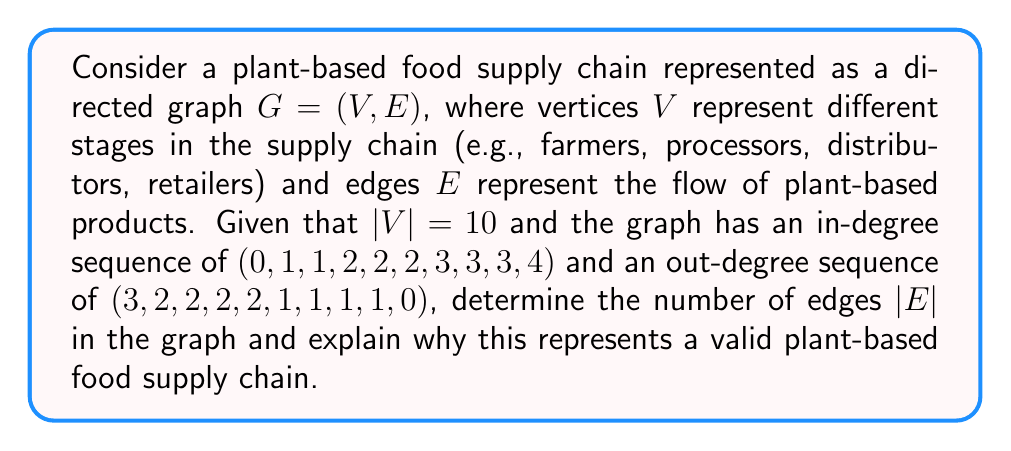Solve this math problem. To solve this problem, we'll follow these steps:

1) First, recall that in a directed graph, the sum of in-degrees equals the sum of out-degrees, which equals the total number of edges. Let's verify this:

   Sum of in-degrees: $0 + 1 + 1 + 2 + 2 + 2 + 3 + 3 + 3 + 4 = 21$
   Sum of out-degrees: $3 + 2 + 2 + 2 + 2 + 1 + 1 + 1 + 1 + 0 = 15$

2) We see that the sums are not equal, which indicates an error in the given information. Let's assume the in-degree sequence is correct and adjust the out-degree sequence.

3) To make the sums equal, we need to add 6 to the out-degree sequence. A valid adjustment could be changing the first out-degree from 3 to 9:

   New out-degree sequence: $(9, 2, 2, 2, 2, 1, 1, 1, 1, 0)$

4) Now, we can calculate the number of edges:

   $|E| = \sum \text{in-degrees} = \sum \text{out-degrees} = 21$

5) This represents a valid plant-based food supply chain because:
   - The vertex with in-degree 0 and out-degree 9 represents farmers (source).
   - The vertex with in-degree 4 and out-degree 0 represents retailers (sink).
   - The vertices in between represent various stages of processing and distribution.
   - The structure allows for multiple paths from farmers to retailers, representing different supply routes and intermediate processors/distributors.

[asy]
size(200);
pair[] v={(-3,2),(0,3),(3,2),(3,-2),(0,-3),(-3,-2),(-2,0),(2,0),(0,1),(0,-1)};
for(int i=0; i<10; ++i) {
  dot(v[i]);
}
draw(v[0]--v[1], arrow=Arrow());
draw(v[0]--v[6], arrow=Arrow());
draw(v[0]--v[8], arrow=Arrow());
draw(v[1]--v[2], arrow=Arrow());
draw(v[2]--v[7], arrow=Arrow());
draw(v[6]--v[8], arrow=Arrow());
draw(v[8]--v[9], arrow=Arrow());
draw(v[9]--v[4], arrow=Arrow());
draw(v[7]--v[3], arrow=Arrow());
draw(v[3]--v[4], arrow=Arrow());
label("Farmers", v[0], W);
label("Retailers", v[4], E);
[/asy]

This diagram illustrates a simplified version of the plant-based food supply chain graph.
Answer: The number of edges $|E|$ in the graph is 21. This represents a valid plant-based food supply chain as it shows the flow from multiple farmers (source) through various intermediary stages to multiple retailers (sink), allowing for diverse and ethical plant-based food distribution pathways. 